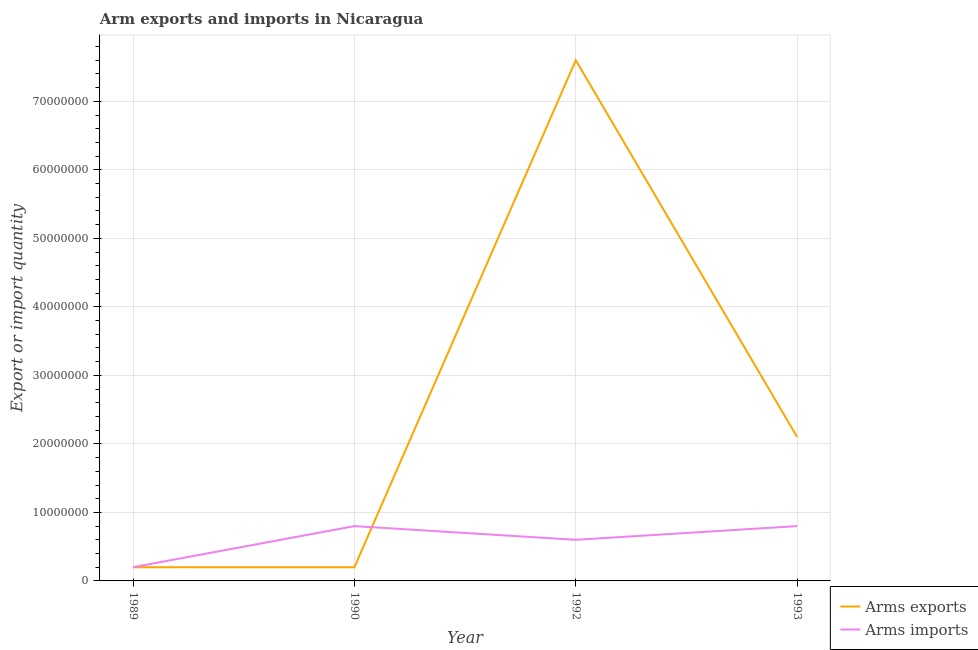How many different coloured lines are there?
Provide a short and direct response. 2. What is the arms imports in 1989?
Provide a succinct answer. 2.00e+06. Across all years, what is the maximum arms exports?
Your answer should be very brief. 7.60e+07. Across all years, what is the minimum arms exports?
Provide a succinct answer. 2.00e+06. What is the total arms imports in the graph?
Your answer should be compact. 2.40e+07. What is the difference between the arms imports in 1989 and that in 1992?
Your answer should be very brief. -4.00e+06. What is the difference between the arms imports in 1989 and the arms exports in 1992?
Ensure brevity in your answer.  -7.40e+07. What is the average arms exports per year?
Offer a very short reply. 2.52e+07. In the year 1989, what is the difference between the arms exports and arms imports?
Your answer should be very brief. 0. What is the ratio of the arms exports in 1992 to that in 1993?
Your response must be concise. 3.62. Is the arms imports in 1989 less than that in 1990?
Give a very brief answer. Yes. Is the difference between the arms exports in 1992 and 1993 greater than the difference between the arms imports in 1992 and 1993?
Offer a terse response. Yes. What is the difference between the highest and the lowest arms imports?
Ensure brevity in your answer.  6.00e+06. In how many years, is the arms imports greater than the average arms imports taken over all years?
Your answer should be compact. 2. Where does the legend appear in the graph?
Provide a short and direct response. Bottom right. How are the legend labels stacked?
Make the answer very short. Vertical. What is the title of the graph?
Provide a succinct answer. Arm exports and imports in Nicaragua. Does "Money lenders" appear as one of the legend labels in the graph?
Your answer should be very brief. No. What is the label or title of the X-axis?
Keep it short and to the point. Year. What is the label or title of the Y-axis?
Your answer should be very brief. Export or import quantity. What is the Export or import quantity of Arms imports in 1990?
Provide a short and direct response. 8.00e+06. What is the Export or import quantity of Arms exports in 1992?
Make the answer very short. 7.60e+07. What is the Export or import quantity of Arms imports in 1992?
Ensure brevity in your answer.  6.00e+06. What is the Export or import quantity in Arms exports in 1993?
Ensure brevity in your answer.  2.10e+07. Across all years, what is the maximum Export or import quantity in Arms exports?
Your answer should be compact. 7.60e+07. Across all years, what is the maximum Export or import quantity in Arms imports?
Provide a succinct answer. 8.00e+06. Across all years, what is the minimum Export or import quantity in Arms exports?
Offer a terse response. 2.00e+06. Across all years, what is the minimum Export or import quantity in Arms imports?
Ensure brevity in your answer.  2.00e+06. What is the total Export or import quantity in Arms exports in the graph?
Provide a succinct answer. 1.01e+08. What is the total Export or import quantity of Arms imports in the graph?
Your answer should be compact. 2.40e+07. What is the difference between the Export or import quantity in Arms imports in 1989 and that in 1990?
Your answer should be compact. -6.00e+06. What is the difference between the Export or import quantity in Arms exports in 1989 and that in 1992?
Provide a succinct answer. -7.40e+07. What is the difference between the Export or import quantity in Arms exports in 1989 and that in 1993?
Offer a terse response. -1.90e+07. What is the difference between the Export or import quantity of Arms imports in 1989 and that in 1993?
Make the answer very short. -6.00e+06. What is the difference between the Export or import quantity in Arms exports in 1990 and that in 1992?
Your response must be concise. -7.40e+07. What is the difference between the Export or import quantity of Arms imports in 1990 and that in 1992?
Offer a very short reply. 2.00e+06. What is the difference between the Export or import quantity of Arms exports in 1990 and that in 1993?
Ensure brevity in your answer.  -1.90e+07. What is the difference between the Export or import quantity of Arms exports in 1992 and that in 1993?
Provide a succinct answer. 5.50e+07. What is the difference between the Export or import quantity of Arms exports in 1989 and the Export or import quantity of Arms imports in 1990?
Your response must be concise. -6.00e+06. What is the difference between the Export or import quantity in Arms exports in 1989 and the Export or import quantity in Arms imports in 1993?
Keep it short and to the point. -6.00e+06. What is the difference between the Export or import quantity of Arms exports in 1990 and the Export or import quantity of Arms imports in 1992?
Make the answer very short. -4.00e+06. What is the difference between the Export or import quantity in Arms exports in 1990 and the Export or import quantity in Arms imports in 1993?
Provide a short and direct response. -6.00e+06. What is the difference between the Export or import quantity of Arms exports in 1992 and the Export or import quantity of Arms imports in 1993?
Make the answer very short. 6.80e+07. What is the average Export or import quantity of Arms exports per year?
Offer a terse response. 2.52e+07. What is the average Export or import quantity in Arms imports per year?
Your answer should be very brief. 6.00e+06. In the year 1989, what is the difference between the Export or import quantity of Arms exports and Export or import quantity of Arms imports?
Make the answer very short. 0. In the year 1990, what is the difference between the Export or import quantity of Arms exports and Export or import quantity of Arms imports?
Make the answer very short. -6.00e+06. In the year 1992, what is the difference between the Export or import quantity in Arms exports and Export or import quantity in Arms imports?
Offer a terse response. 7.00e+07. In the year 1993, what is the difference between the Export or import quantity in Arms exports and Export or import quantity in Arms imports?
Provide a short and direct response. 1.30e+07. What is the ratio of the Export or import quantity of Arms exports in 1989 to that in 1990?
Make the answer very short. 1. What is the ratio of the Export or import quantity in Arms exports in 1989 to that in 1992?
Your response must be concise. 0.03. What is the ratio of the Export or import quantity of Arms exports in 1989 to that in 1993?
Offer a terse response. 0.1. What is the ratio of the Export or import quantity in Arms exports in 1990 to that in 1992?
Your answer should be compact. 0.03. What is the ratio of the Export or import quantity in Arms exports in 1990 to that in 1993?
Your answer should be very brief. 0.1. What is the ratio of the Export or import quantity in Arms exports in 1992 to that in 1993?
Give a very brief answer. 3.62. What is the difference between the highest and the second highest Export or import quantity of Arms exports?
Your answer should be very brief. 5.50e+07. What is the difference between the highest and the lowest Export or import quantity in Arms exports?
Provide a succinct answer. 7.40e+07. 